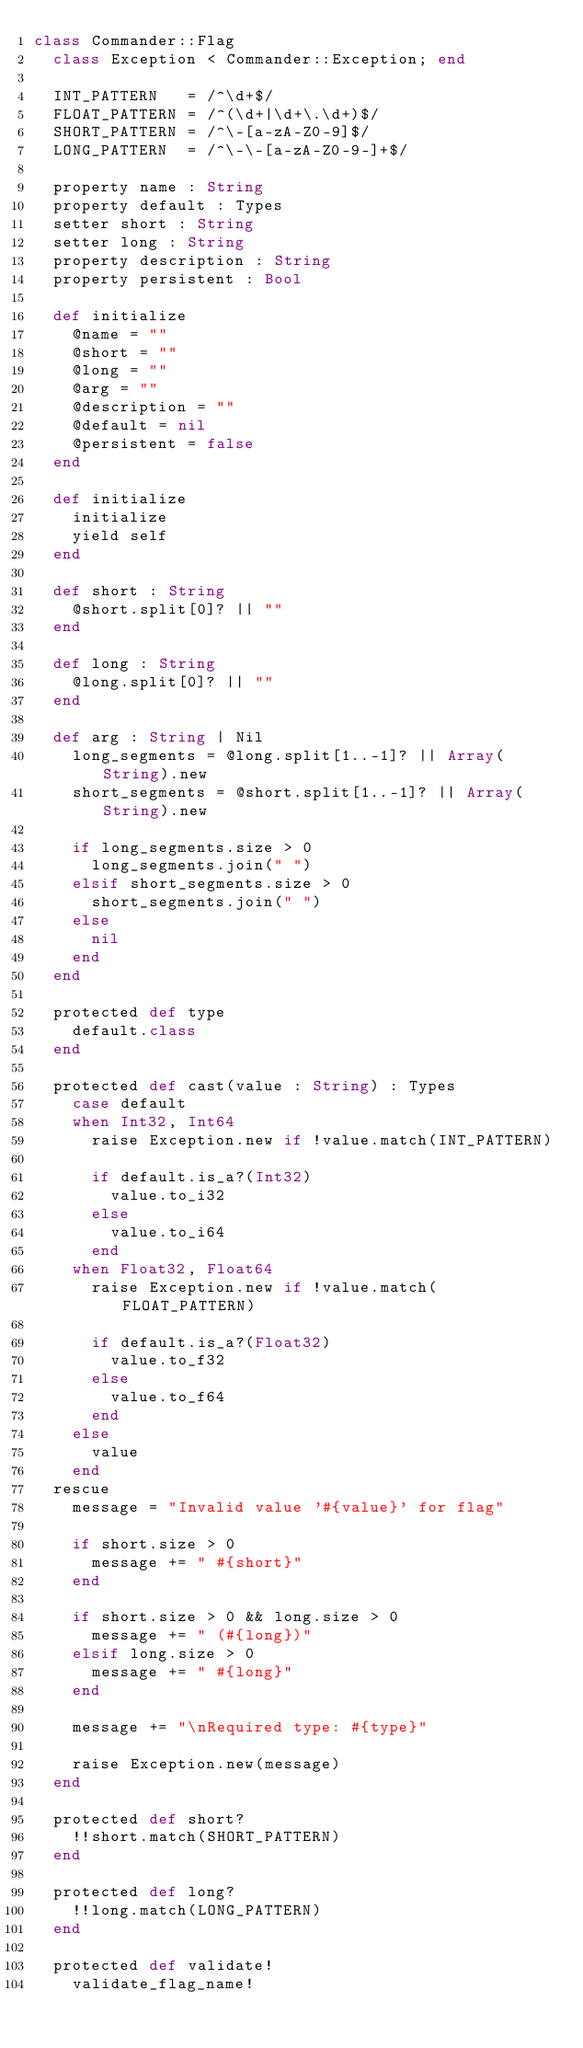<code> <loc_0><loc_0><loc_500><loc_500><_Crystal_>class Commander::Flag
  class Exception < Commander::Exception; end

  INT_PATTERN   = /^\d+$/
  FLOAT_PATTERN = /^(\d+|\d+\.\d+)$/
  SHORT_PATTERN = /^\-[a-zA-Z0-9]$/
  LONG_PATTERN  = /^\-\-[a-zA-Z0-9-]+$/

  property name : String
  property default : Types
  setter short : String
  setter long : String
  property description : String
  property persistent : Bool

  def initialize
    @name = ""
    @short = ""
    @long = ""
    @arg = ""
    @description = ""
    @default = nil
    @persistent = false
  end

  def initialize
    initialize
    yield self
  end

  def short : String
    @short.split[0]? || ""
  end

  def long : String
    @long.split[0]? || ""
  end

  def arg : String | Nil
    long_segments = @long.split[1..-1]? || Array(String).new
    short_segments = @short.split[1..-1]? || Array(String).new

    if long_segments.size > 0
      long_segments.join(" ")
    elsif short_segments.size > 0
      short_segments.join(" ")
    else
      nil
    end
  end

  protected def type
    default.class
  end

  protected def cast(value : String) : Types
    case default
    when Int32, Int64
      raise Exception.new if !value.match(INT_PATTERN)

      if default.is_a?(Int32)
        value.to_i32
      else
        value.to_i64
      end
    when Float32, Float64
      raise Exception.new if !value.match(FLOAT_PATTERN)

      if default.is_a?(Float32)
        value.to_f32
      else
        value.to_f64
      end
    else
      value
    end
  rescue
    message = "Invalid value '#{value}' for flag"

    if short.size > 0
      message += " #{short}"
    end

    if short.size > 0 && long.size > 0
      message += " (#{long})"
    elsif long.size > 0
      message += " #{long}"
    end

    message += "\nRequired type: #{type}"

    raise Exception.new(message)
  end

  protected def short?
    !!short.match(SHORT_PATTERN)
  end

  protected def long?
    !!long.match(LONG_PATTERN)
  end

  protected def validate!
    validate_flag_name!</code> 